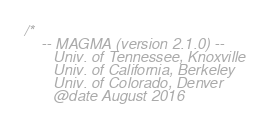<code> <loc_0><loc_0><loc_500><loc_500><_Cuda_>/*
    -- MAGMA (version 2.1.0) --
       Univ. of Tennessee, Knoxville
       Univ. of California, Berkeley
       Univ. of Colorado, Denver
       @date August 2016
</code> 